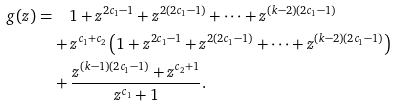Convert formula to latex. <formula><loc_0><loc_0><loc_500><loc_500>g ( z ) = & \quad 1 + z ^ { 2 c _ { 1 } - 1 } + z ^ { 2 ( 2 c _ { 1 } - 1 ) } + \dots + z ^ { ( k - 2 ) ( 2 c _ { 1 } - 1 ) } \\ & + z ^ { c _ { 1 } + c _ { 2 } } \left ( 1 + z ^ { 2 c _ { 1 } - 1 } + z ^ { 2 ( 2 c _ { 1 } - 1 ) } + \dots + z ^ { ( k - 2 ) ( 2 c _ { 1 } - 1 ) } \right ) \\ & + \frac { z ^ { ( k - 1 ) ( 2 c _ { 1 } - 1 ) } + z ^ { c _ { 2 } + 1 } } { z ^ { c _ { 1 } } + 1 } .</formula> 